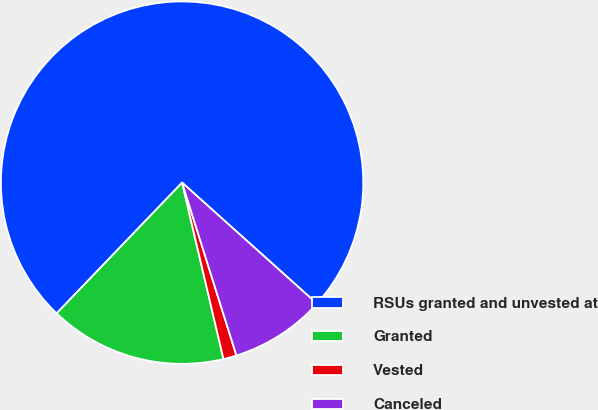Convert chart to OTSL. <chart><loc_0><loc_0><loc_500><loc_500><pie_chart><fcel>RSUs granted and unvested at<fcel>Granted<fcel>Vested<fcel>Canceled<nl><fcel>74.47%<fcel>15.84%<fcel>1.18%<fcel>8.51%<nl></chart> 